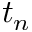Convert formula to latex. <formula><loc_0><loc_0><loc_500><loc_500>t _ { n }</formula> 